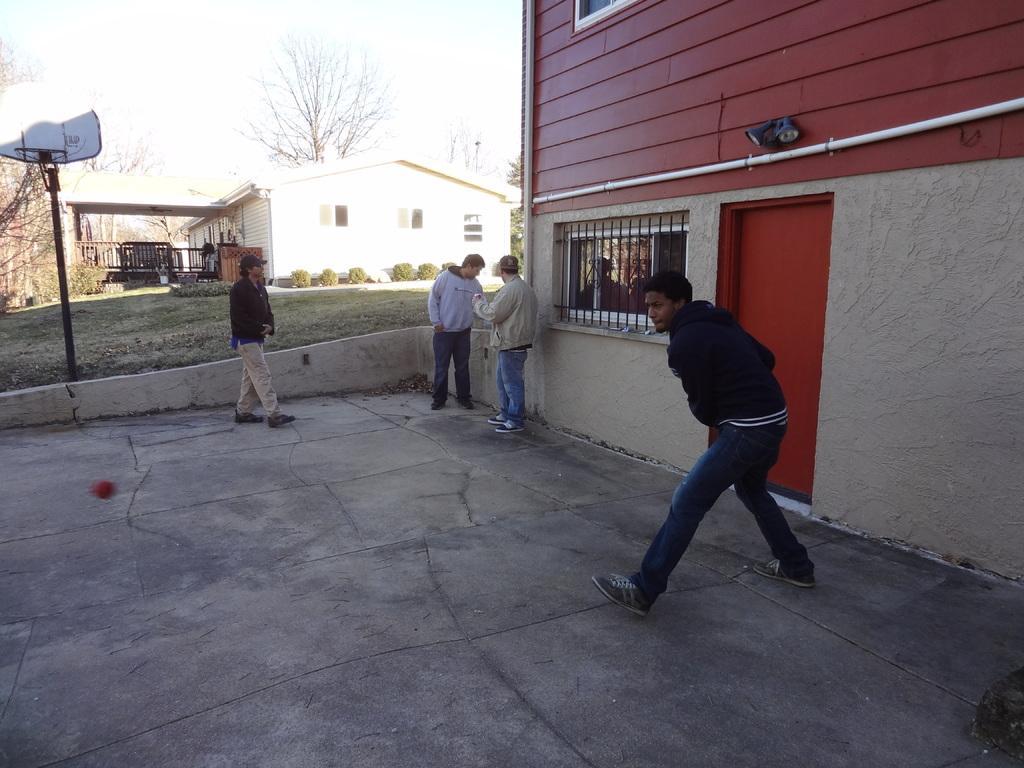Can you describe this image briefly? In this picture we can see there are four people standing on the path and behind the people there are house, plants, pole and a sky. 